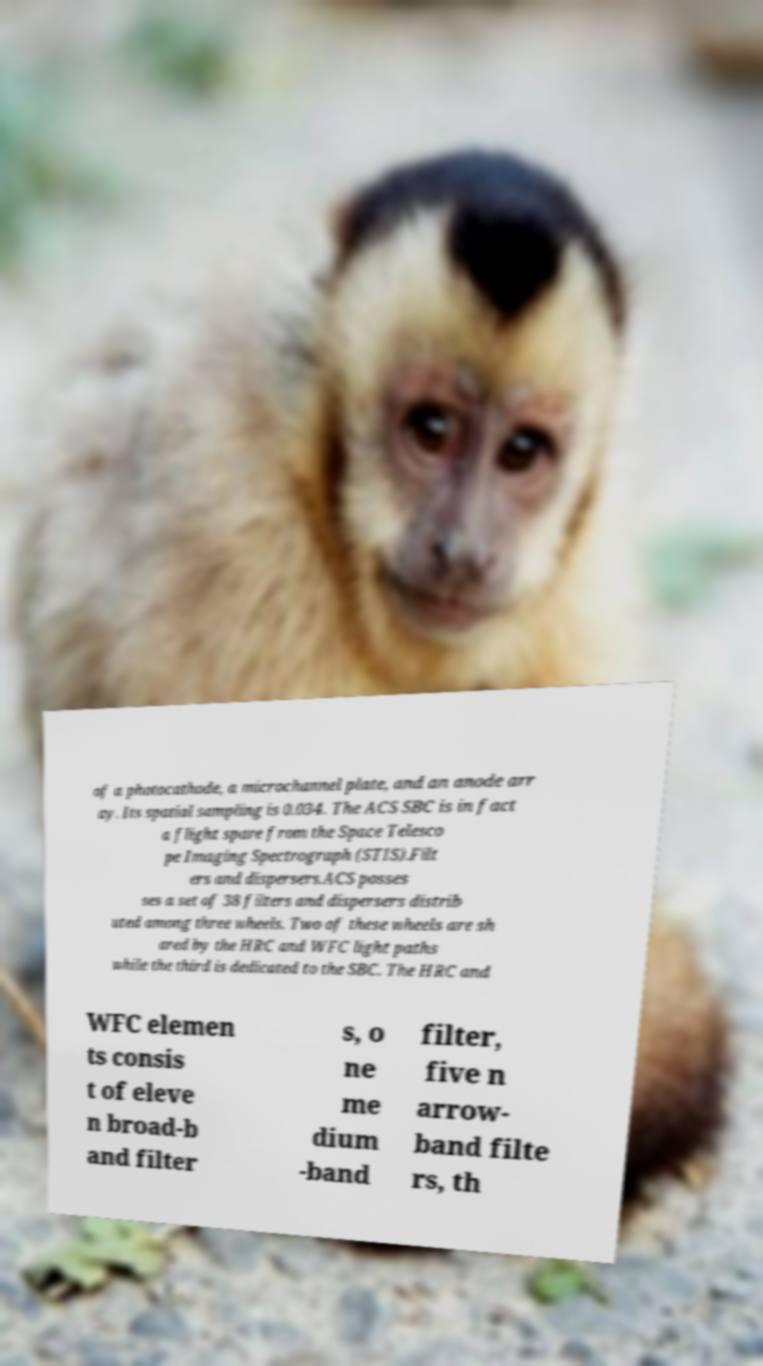There's text embedded in this image that I need extracted. Can you transcribe it verbatim? of a photocathode, a microchannel plate, and an anode arr ay. Its spatial sampling is 0.034. The ACS SBC is in fact a flight spare from the Space Telesco pe Imaging Spectrograph (STIS).Filt ers and dispersers.ACS posses ses a set of 38 filters and dispersers distrib uted among three wheels. Two of these wheels are sh ared by the HRC and WFC light paths while the third is dedicated to the SBC. The HRC and WFC elemen ts consis t of eleve n broad-b and filter s, o ne me dium -band filter, five n arrow- band filte rs, th 